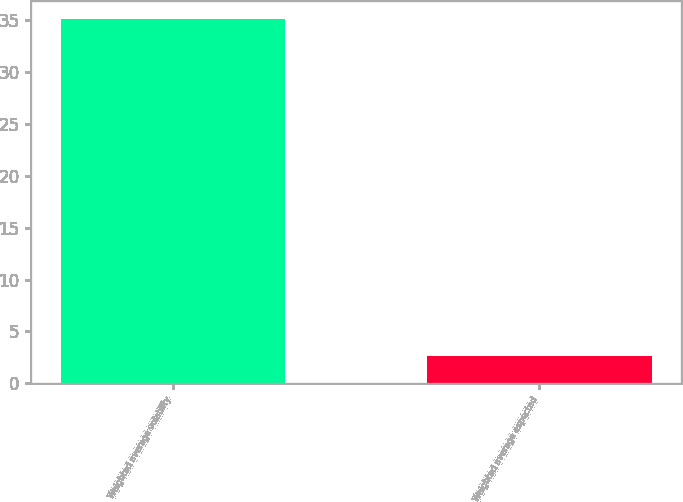Convert chart. <chart><loc_0><loc_0><loc_500><loc_500><bar_chart><fcel>Weighted average volatility<fcel>Weighted average expected<nl><fcel>35.1<fcel>2.6<nl></chart> 